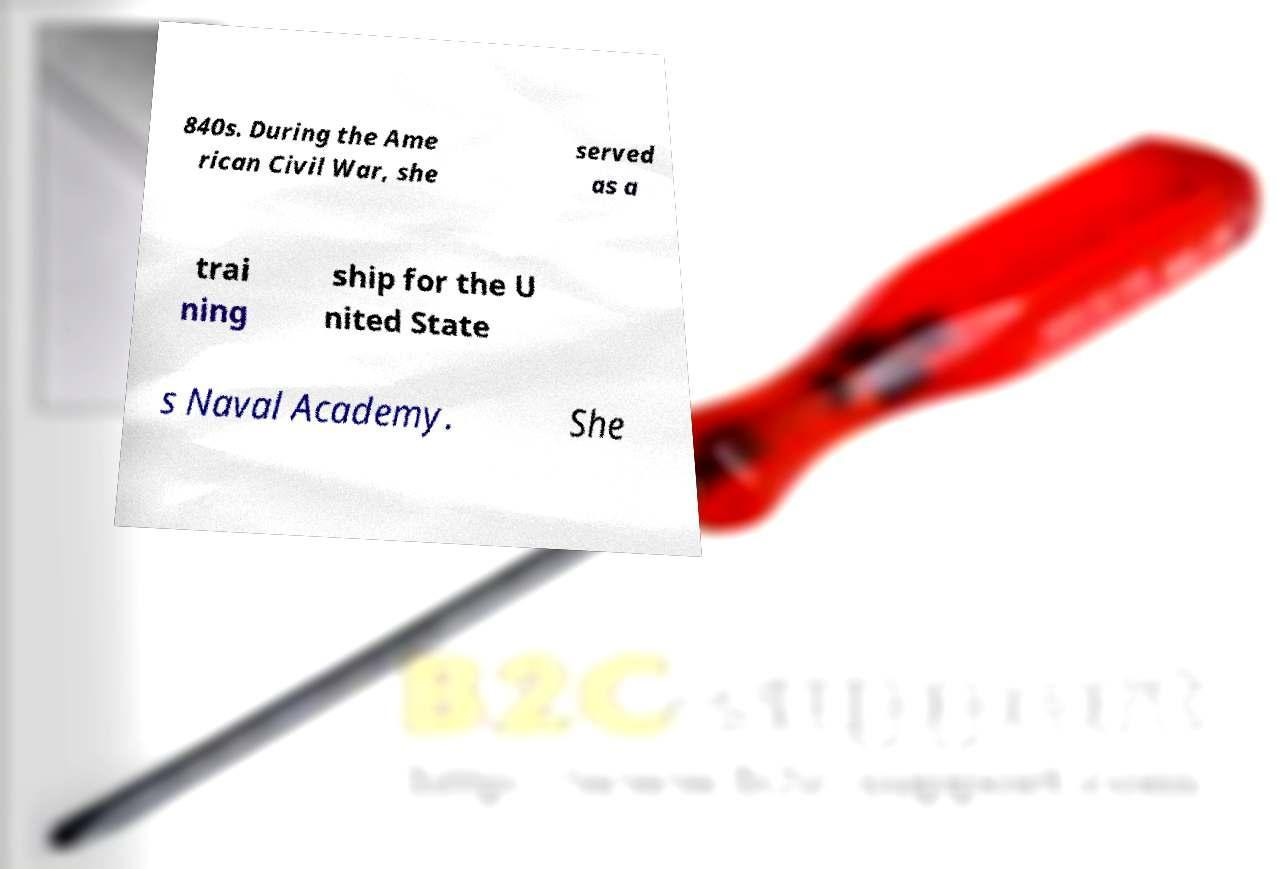Could you assist in decoding the text presented in this image and type it out clearly? 840s. During the Ame rican Civil War, she served as a trai ning ship for the U nited State s Naval Academy. She 